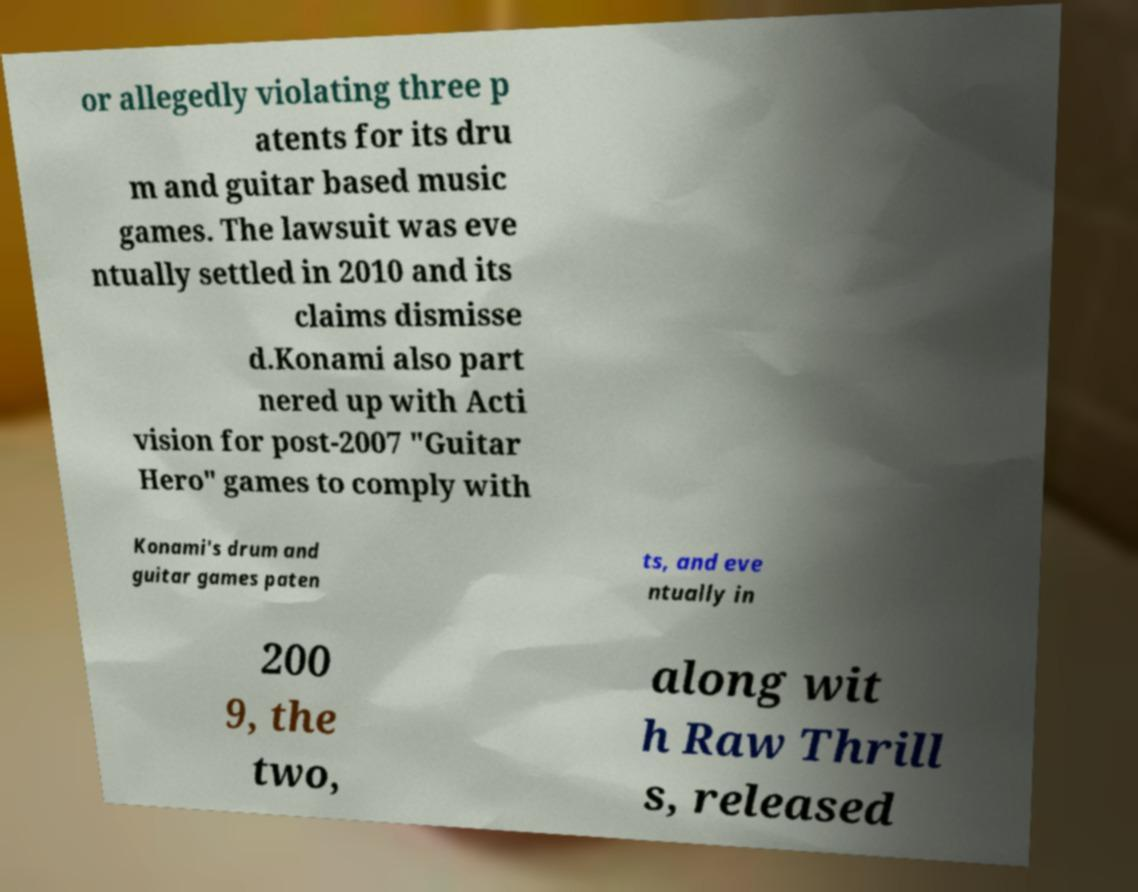What messages or text are displayed in this image? I need them in a readable, typed format. or allegedly violating three p atents for its dru m and guitar based music games. The lawsuit was eve ntually settled in 2010 and its claims dismisse d.Konami also part nered up with Acti vision for post-2007 "Guitar Hero" games to comply with Konami's drum and guitar games paten ts, and eve ntually in 200 9, the two, along wit h Raw Thrill s, released 